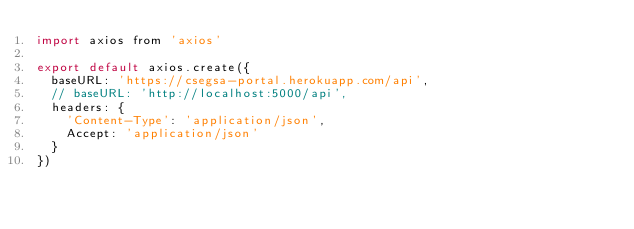<code> <loc_0><loc_0><loc_500><loc_500><_JavaScript_>import axios from 'axios'

export default axios.create({
  baseURL: 'https://csegsa-portal.herokuapp.com/api',
  // baseURL: 'http://localhost:5000/api',
  headers: {
    'Content-Type': 'application/json',
    Accept: 'application/json'
  }
})
</code> 